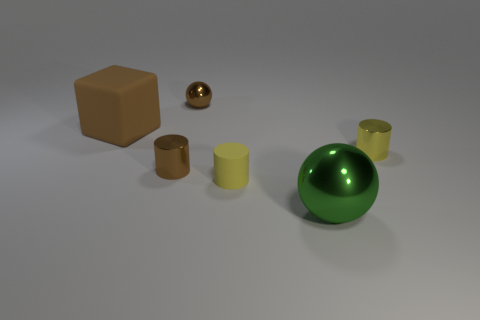There is a shiny cylinder that is the same color as the tiny matte cylinder; what is its size?
Your answer should be compact. Small. What is the shape of the tiny yellow thing in front of the tiny brown cylinder?
Your response must be concise. Cylinder. Are there fewer tiny brown balls than gray metal cubes?
Provide a short and direct response. No. There is a brown metal thing that is behind the tiny thing on the right side of the large green metal ball; is there a tiny metal object that is to the left of it?
Your response must be concise. Yes. How many matte things are green spheres or tiny balls?
Provide a short and direct response. 0. Do the cube and the tiny ball have the same color?
Offer a very short reply. Yes. There is a tiny brown cylinder; how many tiny cylinders are in front of it?
Provide a short and direct response. 1. What number of small metallic cylinders are to the left of the big metallic object and on the right side of the green metallic sphere?
Offer a terse response. 0. There is a yellow object that is made of the same material as the green sphere; what is its shape?
Ensure brevity in your answer.  Cylinder. There is a brown object behind the brown block; is its size the same as the yellow thing behind the brown cylinder?
Make the answer very short. Yes. 